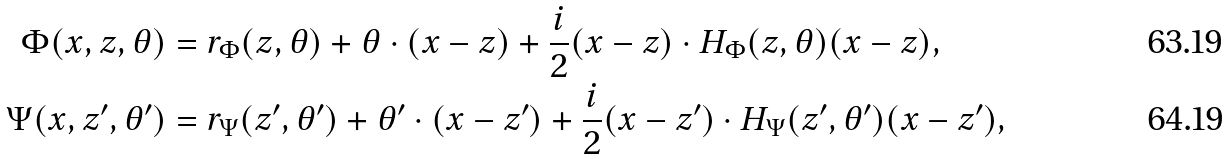Convert formula to latex. <formula><loc_0><loc_0><loc_500><loc_500>\Phi ( x , z , \theta ) & = r _ { \Phi } ( z , \theta ) + \theta \cdot ( x - z ) + \frac { i } { 2 } ( x - z ) \cdot H _ { \Phi } ( z , \theta ) ( x - z ) , \\ \Psi ( x , z ^ { \prime } , \theta ^ { \prime } ) & = r _ { \Psi } ( z ^ { \prime } , \theta ^ { \prime } ) + \theta ^ { \prime } \cdot ( x - z ^ { \prime } ) + \frac { i } { 2 } ( x - z ^ { \prime } ) \cdot H _ { \Psi } ( z ^ { \prime } , \theta ^ { \prime } ) ( x - z ^ { \prime } ) ,</formula> 